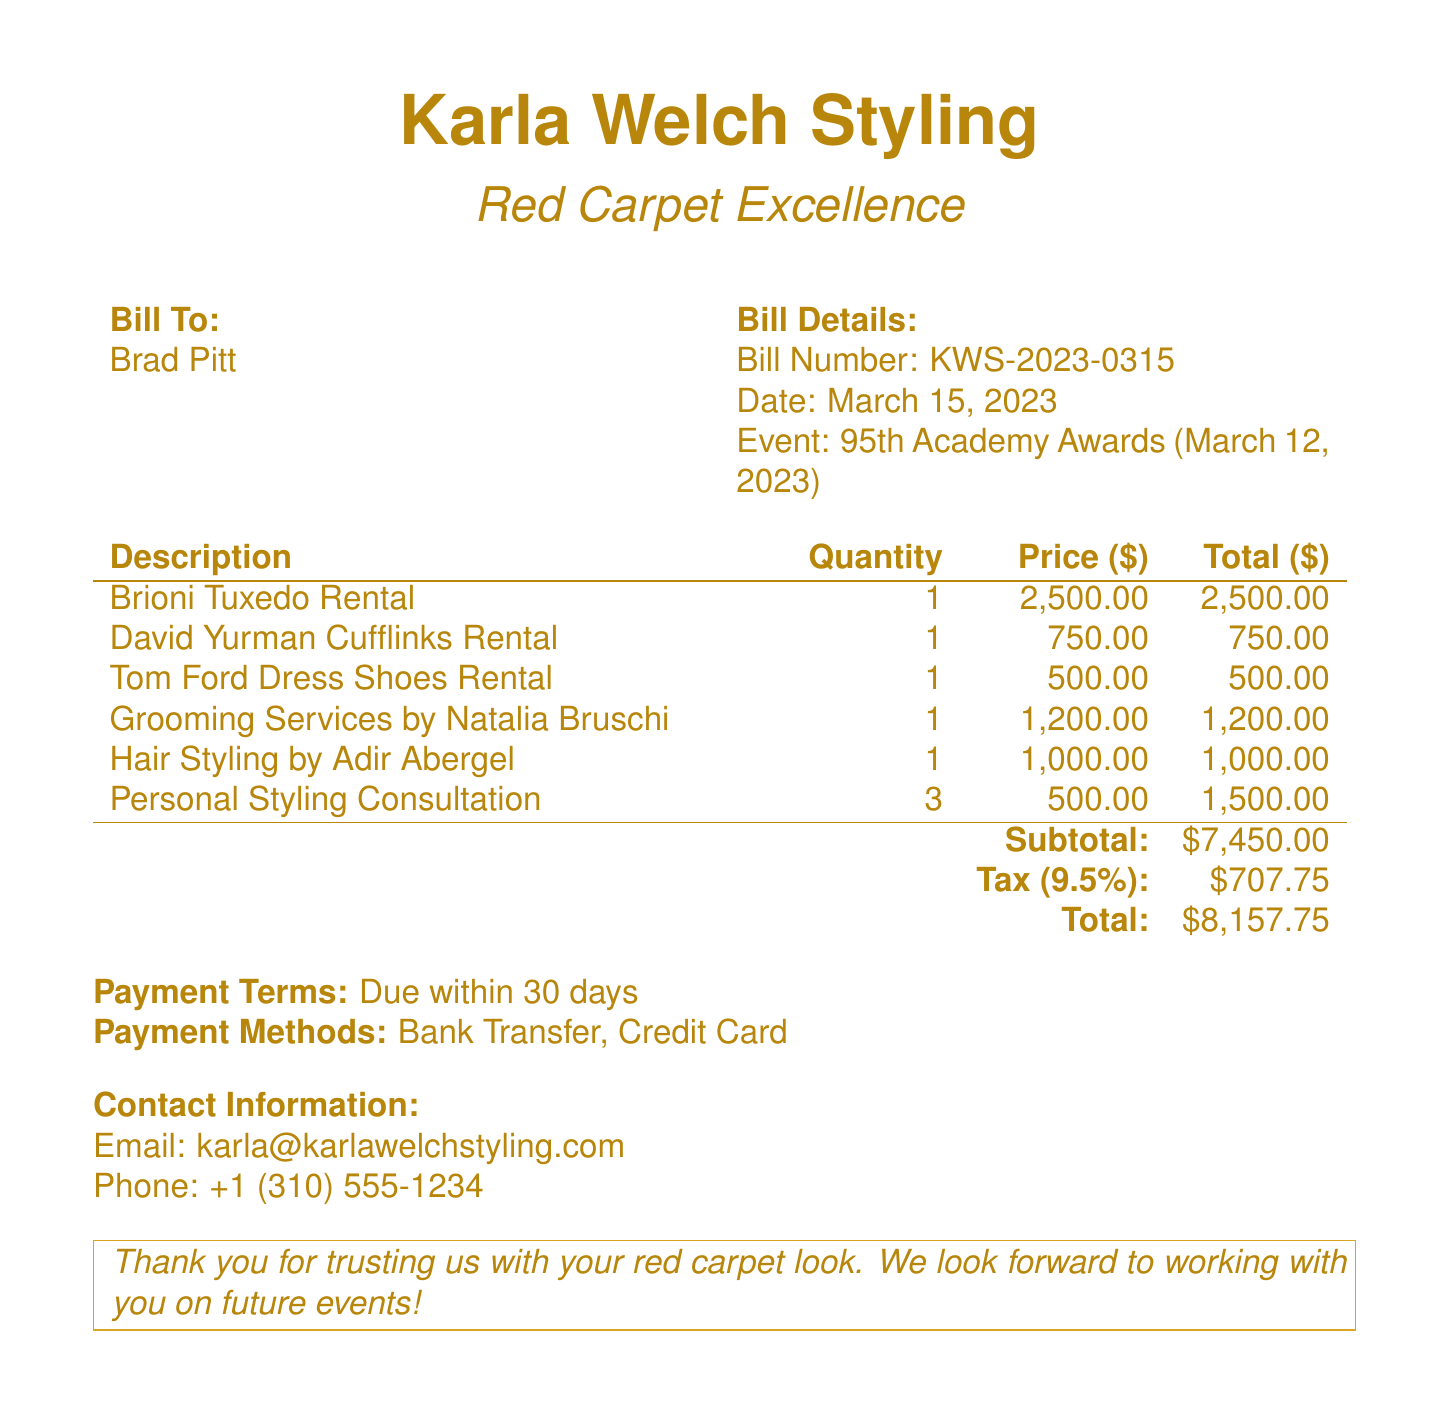what is the bill number? The bill number is a unique identifier for the document listed under Bill Details.
Answer: KWS-2023-0315 who is the bill addressed to? The "Bill To" section specifies the recipient of the bill.
Answer: Brad Pitt when was the bill issued? The date provided in the Bill Details indicates when the bill was generated.
Answer: March 15, 2023 what is the total amount due? The total amount reflects the sum of the subtotal and tax as shown at the bottom of the document.
Answer: $8,157.75 how many personal styling consultations were included? This is the quantity listed under the description of Personal Styling Consultation in the bill.
Answer: 3 what percentage is the tax rate? The document specifies the tax rate applied to the subtotal amount.
Answer: 9.5% who provided the grooming services? The name listed next to Grooming Services in the bill identifies the person who provided the service.
Answer: Natalia Bruschi what is the payment term? The payment terms specify by when the payment is expected.
Answer: Due within 30 days which designer’s tuxedo was rented? The description in the bill specifies which tuxedo was rented for the event.
Answer: Brioni Tuxedo Rental 